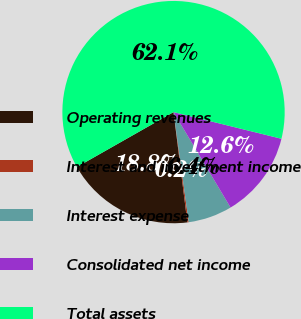Convert chart to OTSL. <chart><loc_0><loc_0><loc_500><loc_500><pie_chart><fcel>Operating revenues<fcel>Interest and investment income<fcel>Interest expense<fcel>Consolidated net income<fcel>Total assets<nl><fcel>18.76%<fcel>0.2%<fcel>6.39%<fcel>12.57%<fcel>62.08%<nl></chart> 